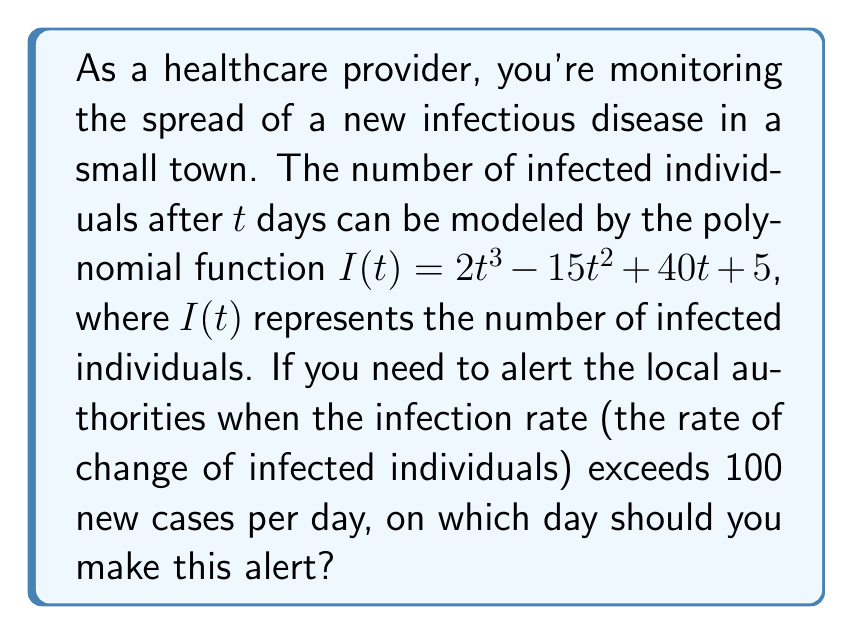Could you help me with this problem? To solve this problem, we need to follow these steps:

1) The infection rate is represented by the derivative of $I(t)$. Let's call this function $I'(t)$.

2) To find $I'(t)$, we differentiate $I(t)$:

   $I'(t) = \frac{d}{dt}(2t^3 - 15t^2 + 40t + 5)$
   $I'(t) = 6t^2 - 30t + 40$

3) We need to find when $I'(t) > 100$. This gives us the inequality:

   $6t^2 - 30t + 40 > 100$

4) Rearranging the inequality:

   $6t^2 - 30t - 60 > 0$

5) This is a quadratic inequality. To solve it, we first find the roots of the quadratic equation $6t^2 - 30t - 60 = 0$

6) Using the quadratic formula, $t = \frac{-b \pm \sqrt{b^2 - 4ac}}{2a}$, where $a=6$, $b=-30$, and $c=-60$:

   $t = \frac{30 \pm \sqrt{900 + 1440}}{12} = \frac{30 \pm \sqrt{2340}}{12}$

7) Simplifying:

   $t = \frac{30 \pm 48.37}{12} \approx 6.53$ or $-1.53$

8) The parabola opens upward because the coefficient of $t^2$ is positive. Therefore, the inequality $6t^2 - 30t - 60 > 0$ is satisfied when $t < -1.53$ or $t > 6.53$

9) Since time cannot be negative in this context, we're only interested in $t > 6.53$

10) The smallest integer $t$ that satisfies this is 7.

Therefore, you should alert the authorities on day 7.
Answer: Day 7 